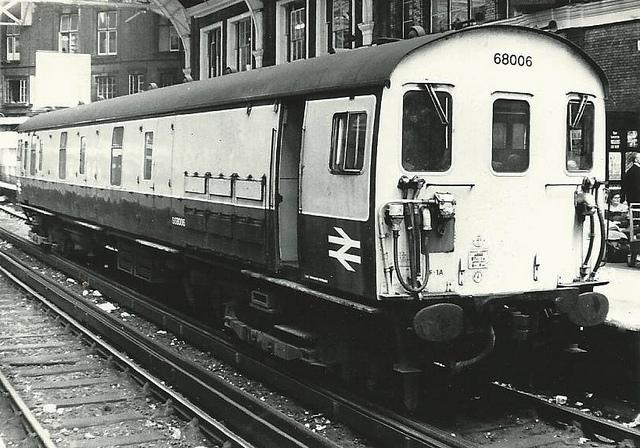What number is the largest number on the train?

Choices:
A) five
B) two
C) eight
D) seven eight 